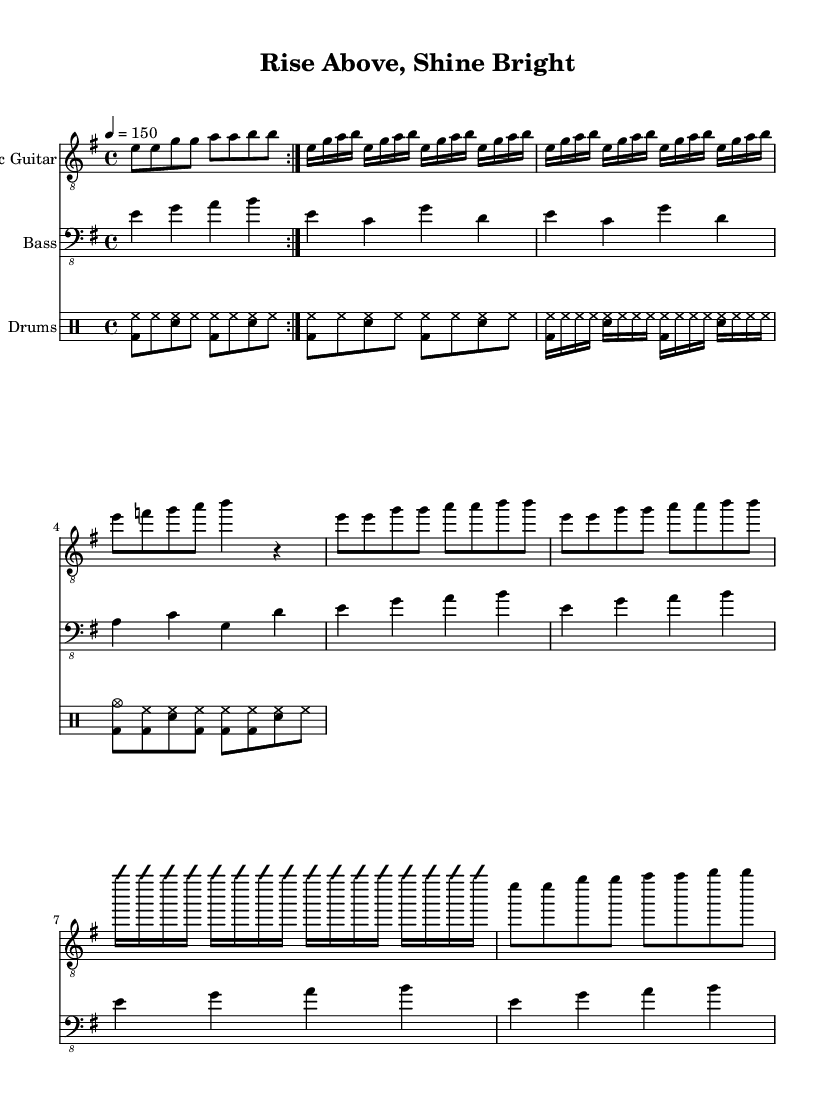What is the key signature of this music? The key signature is indicated by the 'key e minor' in the global section. E minor has one sharp (F#).
Answer: E minor What is the time signature of this piece? The time signature is shown as 'time 4/4' in the global section at the beginning of the sheet music. This means there are four beats per measure.
Answer: 4/4 What is the tempo marking for this piece? The tempo marking is provided as 'tempo 4 = 150', indicating that the tempo is 150 beats per minute.
Answer: 150 How many measures are there in the chorus section? The chorus section consists of two lines of music, each totalizing four measures (hence, 8 measures total), as visible when counting the measure bars.
Answer: 8 What instrument plays the improvised solo section? The improvisation section is indicated for the 'Electric Guitar' part, as it is noted with 'improvisationOn' and 'improvisationOff' in that specific staff.
Answer: Electric Guitar What type of rhythm pattern is used in the drum part? The drum part uses a 'basic rock beat', evident from the notation indicating bass drums (bd), snare (sn), and hi-hat (hh), characteristic of rock music.
Answer: Basic rock beat What is the overall theme conveyed in the title of this piece? The title "Rise Above, Shine Bright" suggests themes of empowerment and personal triumph, commonly found in power metal anthems that celebrate individual accomplishments.
Answer: Empowerment 